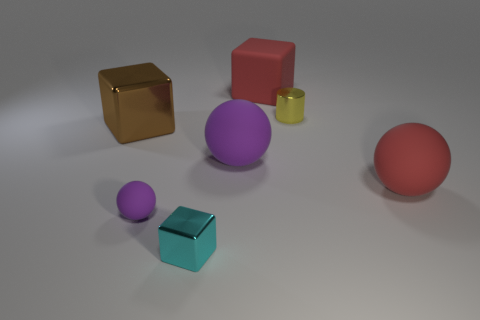Subtract all big cubes. How many cubes are left? 1 Subtract 0 gray cubes. How many objects are left? 7 Subtract all cylinders. How many objects are left? 6 Subtract 3 cubes. How many cubes are left? 0 Subtract all red blocks. Subtract all gray balls. How many blocks are left? 2 Subtract all gray spheres. How many brown blocks are left? 1 Subtract all small red balls. Subtract all big brown objects. How many objects are left? 6 Add 1 large red cubes. How many large red cubes are left? 2 Add 1 large brown metallic blocks. How many large brown metallic blocks exist? 2 Add 2 tiny cyan shiny objects. How many objects exist? 9 